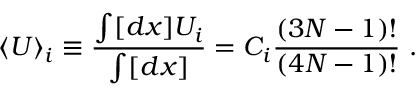<formula> <loc_0><loc_0><loc_500><loc_500>\langle U \rangle _ { i } \equiv \frac { \int [ d x ] U _ { i } } { \int [ d x ] } = C _ { i } { \frac { ( 3 N - 1 ) ! } { ( 4 N - 1 ) ! } } .</formula> 